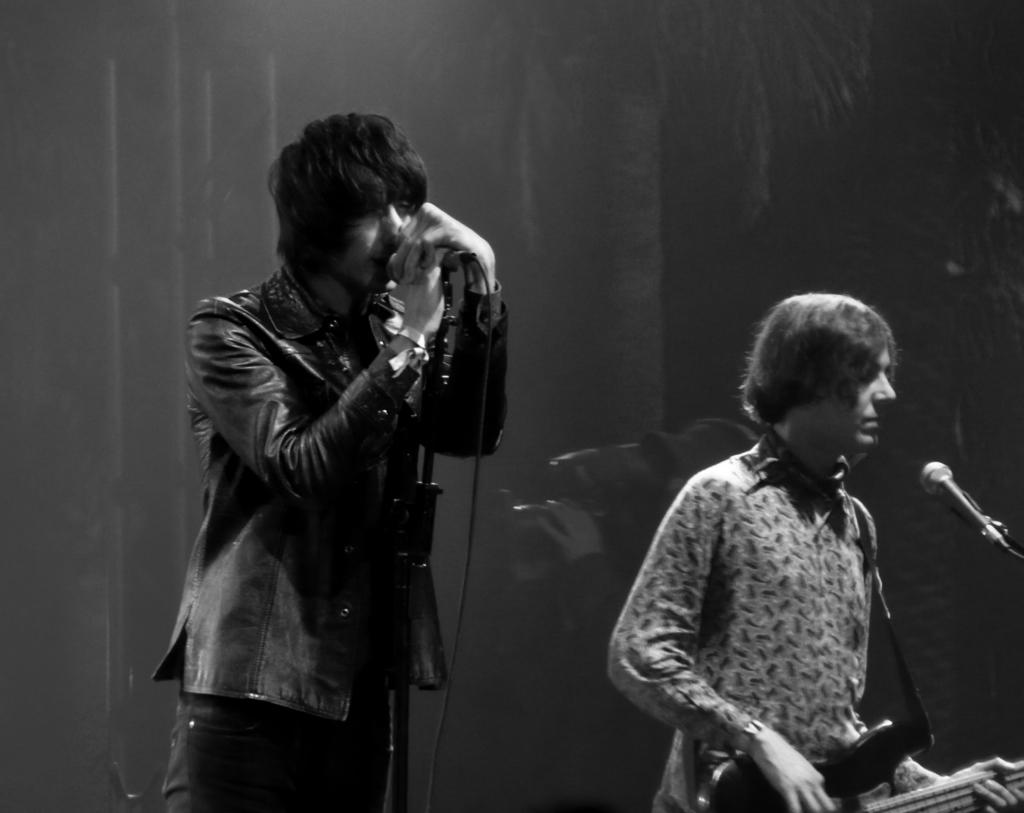What is the man in the image doing? The man is singing in the image. How is the man amplifying his voice? The man is using a microphone in the image. Are there any other people in the image? Yes, there is another man in the image. What is the other man doing? The other man is playing a guitar in the image. What type of wire is being used to hold the dinner in the image? There is no wire or dinner present in the image. 